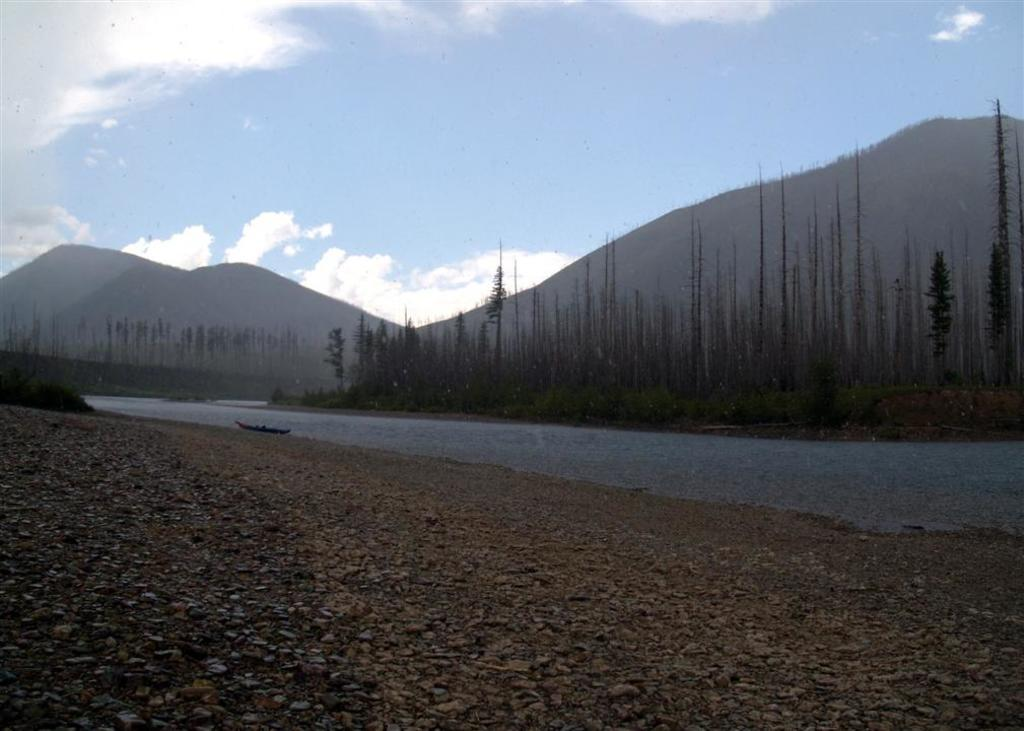What is the main subject of the image? The main subject of the image is a boat. Where is the boat located? The boat is on the water. What can be seen in the background of the image? There are trees, mountains, and the sky visible in the background of the image. What type of brush is being used by the company in the image? There is no company or brush present in the image; it features a boat on the water with trees, mountains, and the sky in the background. 